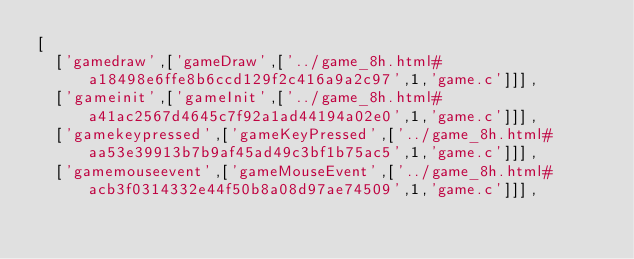Convert code to text. <code><loc_0><loc_0><loc_500><loc_500><_JavaScript_>[
  ['gamedraw',['gameDraw',['../game_8h.html#a18498e6ffe8b6ccd129f2c416a9a2c97',1,'game.c']]],
  ['gameinit',['gameInit',['../game_8h.html#a41ac2567d4645c7f92a1ad44194a02e0',1,'game.c']]],
  ['gamekeypressed',['gameKeyPressed',['../game_8h.html#aa53e39913b7b9af45ad49c3bf1b75ac5',1,'game.c']]],
  ['gamemouseevent',['gameMouseEvent',['../game_8h.html#acb3f0314332e44f50b8a08d97ae74509',1,'game.c']]],</code> 